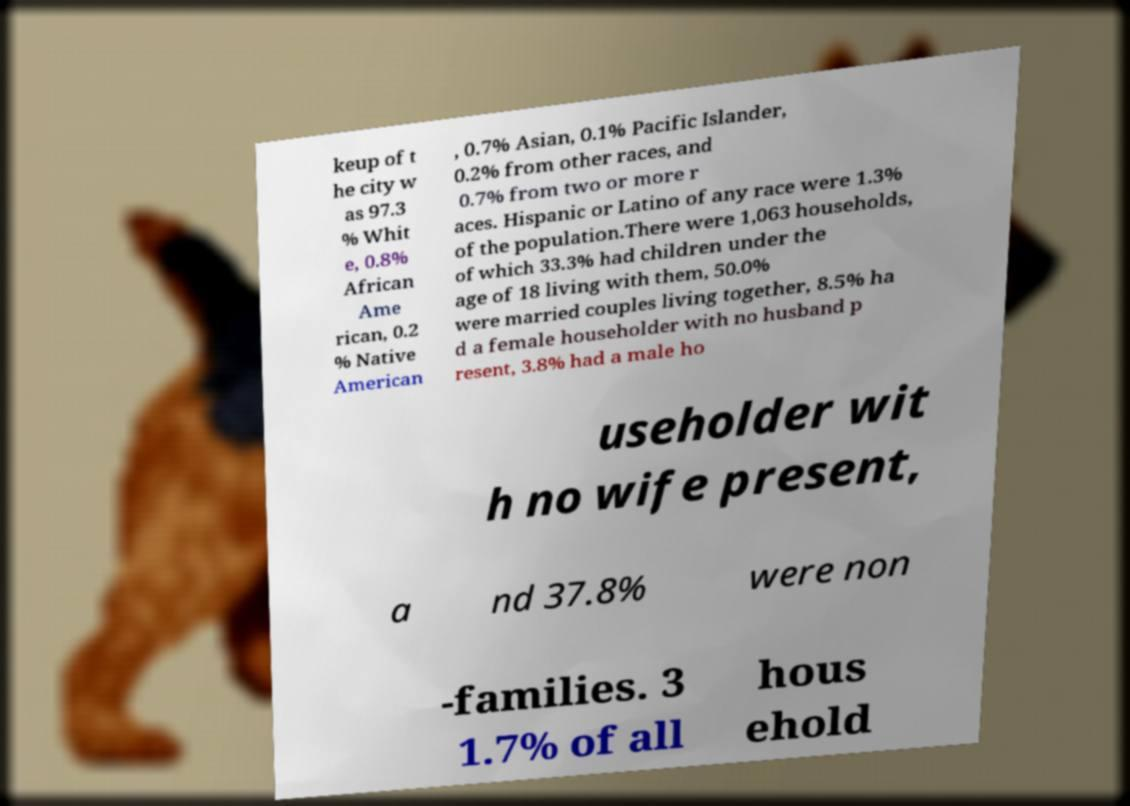Please identify and transcribe the text found in this image. keup of t he city w as 97.3 % Whit e, 0.8% African Ame rican, 0.2 % Native American , 0.7% Asian, 0.1% Pacific Islander, 0.2% from other races, and 0.7% from two or more r aces. Hispanic or Latino of any race were 1.3% of the population.There were 1,063 households, of which 33.3% had children under the age of 18 living with them, 50.0% were married couples living together, 8.5% ha d a female householder with no husband p resent, 3.8% had a male ho useholder wit h no wife present, a nd 37.8% were non -families. 3 1.7% of all hous ehold 